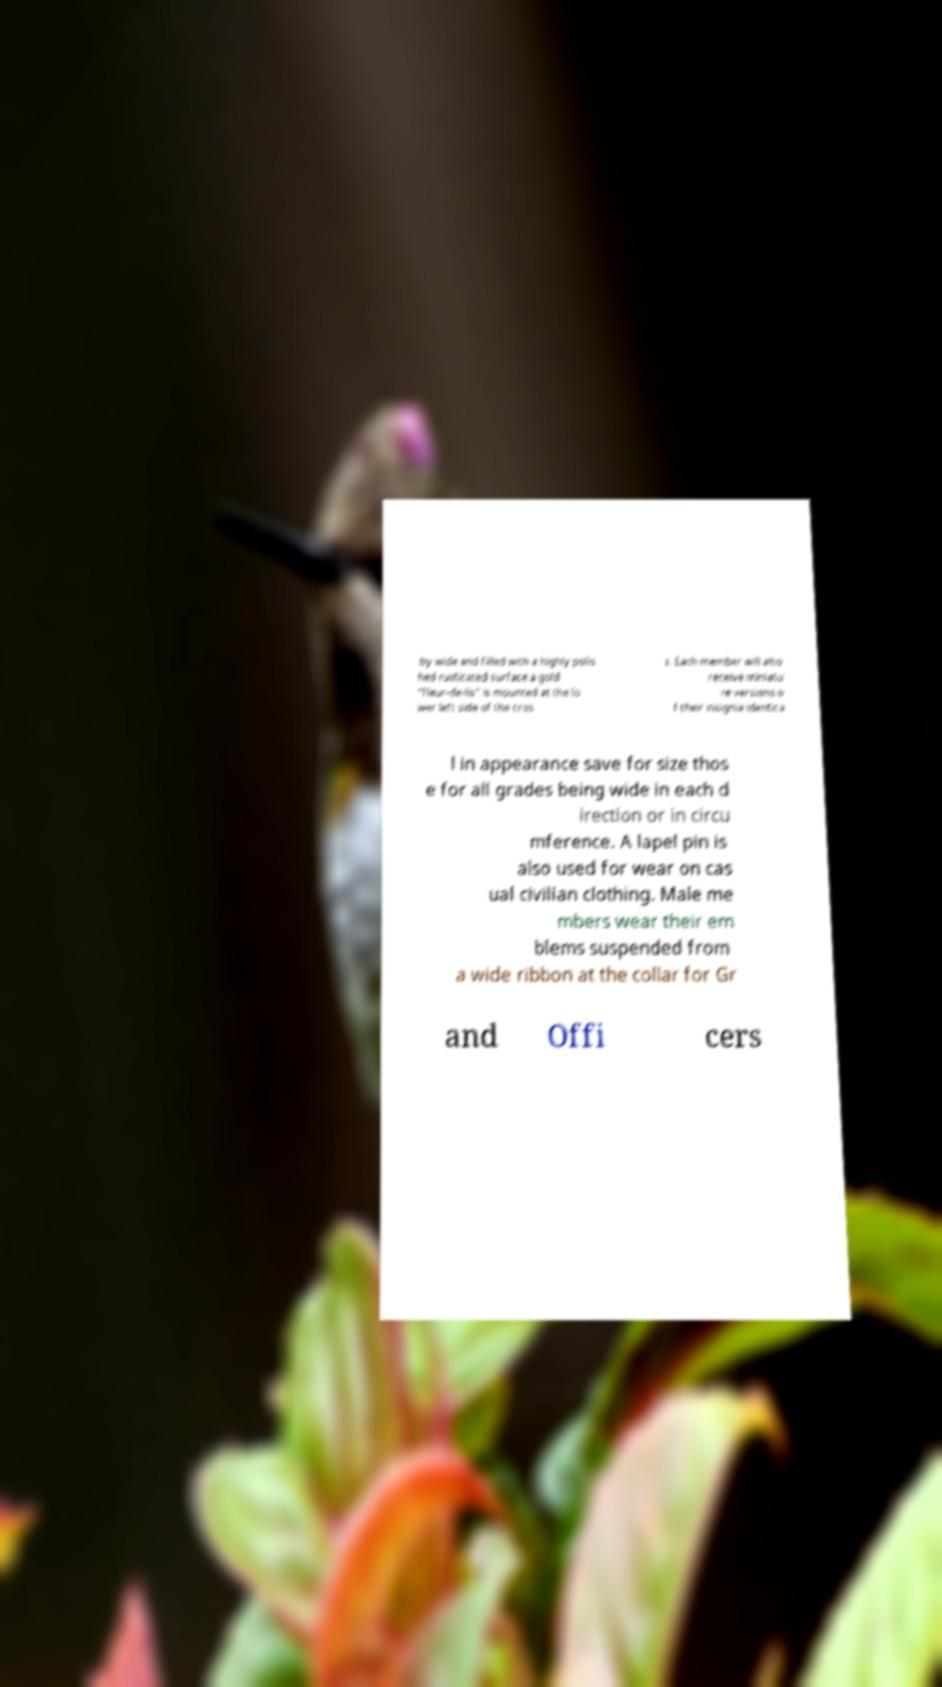For documentation purposes, I need the text within this image transcribed. Could you provide that? by wide and filled with a highly polis hed rusticated surface a gold "fleur-de-lis" is mounted at the lo wer left side of the cros s. Each member will also receive miniatu re versions o f their insignia identica l in appearance save for size thos e for all grades being wide in each d irection or in circu mference. A lapel pin is also used for wear on cas ual civilian clothing. Male me mbers wear their em blems suspended from a wide ribbon at the collar for Gr and Offi cers 